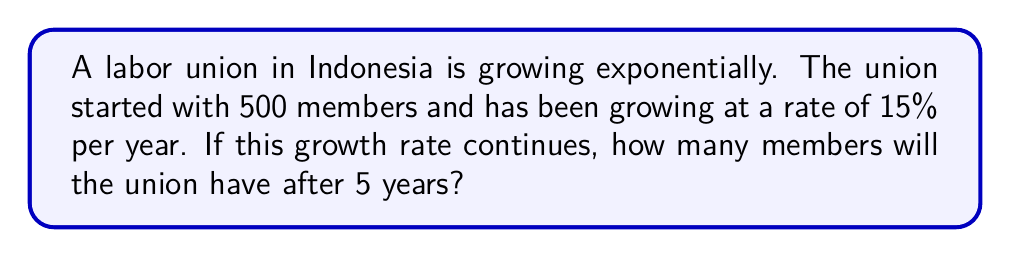Can you solve this math problem? To solve this problem, we'll use the exponential growth formula:

$A = P(1 + r)^t$

Where:
$A$ = final amount
$P$ = initial amount (principal)
$r$ = growth rate (as a decimal)
$t$ = time period

Given:
$P = 500$ (initial members)
$r = 0.15$ (15% growth rate)
$t = 5$ years

Let's substitute these values into the formula:

$A = 500(1 + 0.15)^5$

Now, let's calculate step by step:

1) $A = 500(1.15)^5$

2) $A = 500 \times 2.0113689$

3) $A = 1005.68445$

Since we can't have fractional members, we round to the nearest whole number.

$A \approx 1006$ members
Answer: 1006 members 